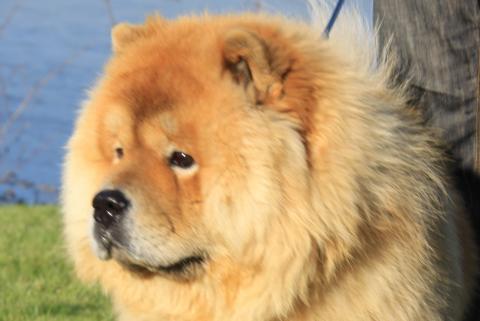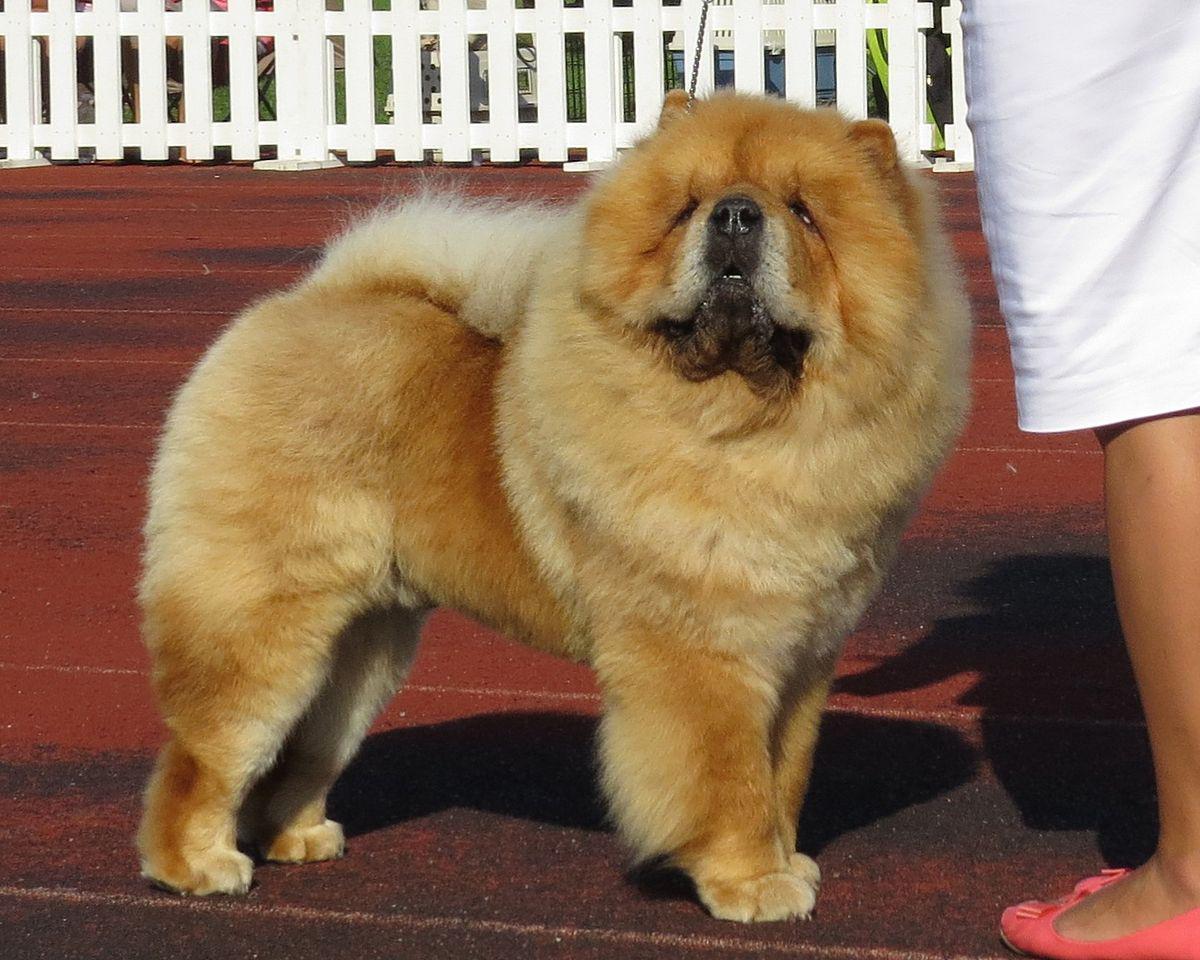The first image is the image on the left, the second image is the image on the right. For the images shown, is this caption "You can see one dog's feet in the grass." true? Answer yes or no. No. The first image is the image on the left, the second image is the image on the right. Examine the images to the left and right. Is the description "One of the dogs is on a leash outdoors, in front of a leg clad in pants." accurate? Answer yes or no. Yes. 